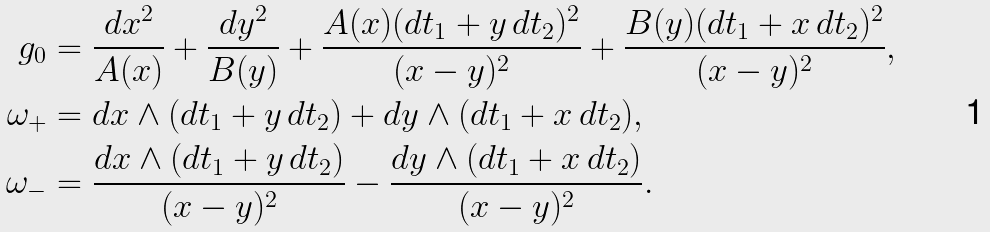<formula> <loc_0><loc_0><loc_500><loc_500>g _ { 0 } & = \frac { d x ^ { 2 } } { A ( x ) } + \frac { d y ^ { 2 } } { B ( y ) } + \frac { A ( x ) ( d t _ { 1 } + y \, d t _ { 2 } ) ^ { 2 } } { ( x - y ) ^ { 2 } } + \frac { B ( y ) ( d t _ { 1 } + x \, d t _ { 2 } ) ^ { 2 } } { ( x - y ) ^ { 2 } } , \\ \omega _ { + } & = d x \wedge ( d t _ { 1 } + y \, d t _ { 2 } ) + d y \wedge ( d t _ { 1 } + x \, d t _ { 2 } ) , \\ \omega _ { - } & = \frac { d x \wedge ( d t _ { 1 } + y \, d t _ { 2 } ) } { ( x - y ) ^ { 2 } } - \frac { d y \wedge ( d t _ { 1 } + x \, d t _ { 2 } ) } { ( x - y ) ^ { 2 } } .</formula> 